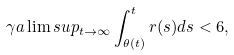<formula> <loc_0><loc_0><loc_500><loc_500>\gamma a \lim s u p _ { t \rightarrow \infty } \int _ { \theta ( t ) } ^ { t } r ( s ) d s < 6 ,</formula> 